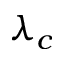Convert formula to latex. <formula><loc_0><loc_0><loc_500><loc_500>\lambda _ { c }</formula> 